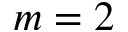Convert formula to latex. <formula><loc_0><loc_0><loc_500><loc_500>m = 2</formula> 